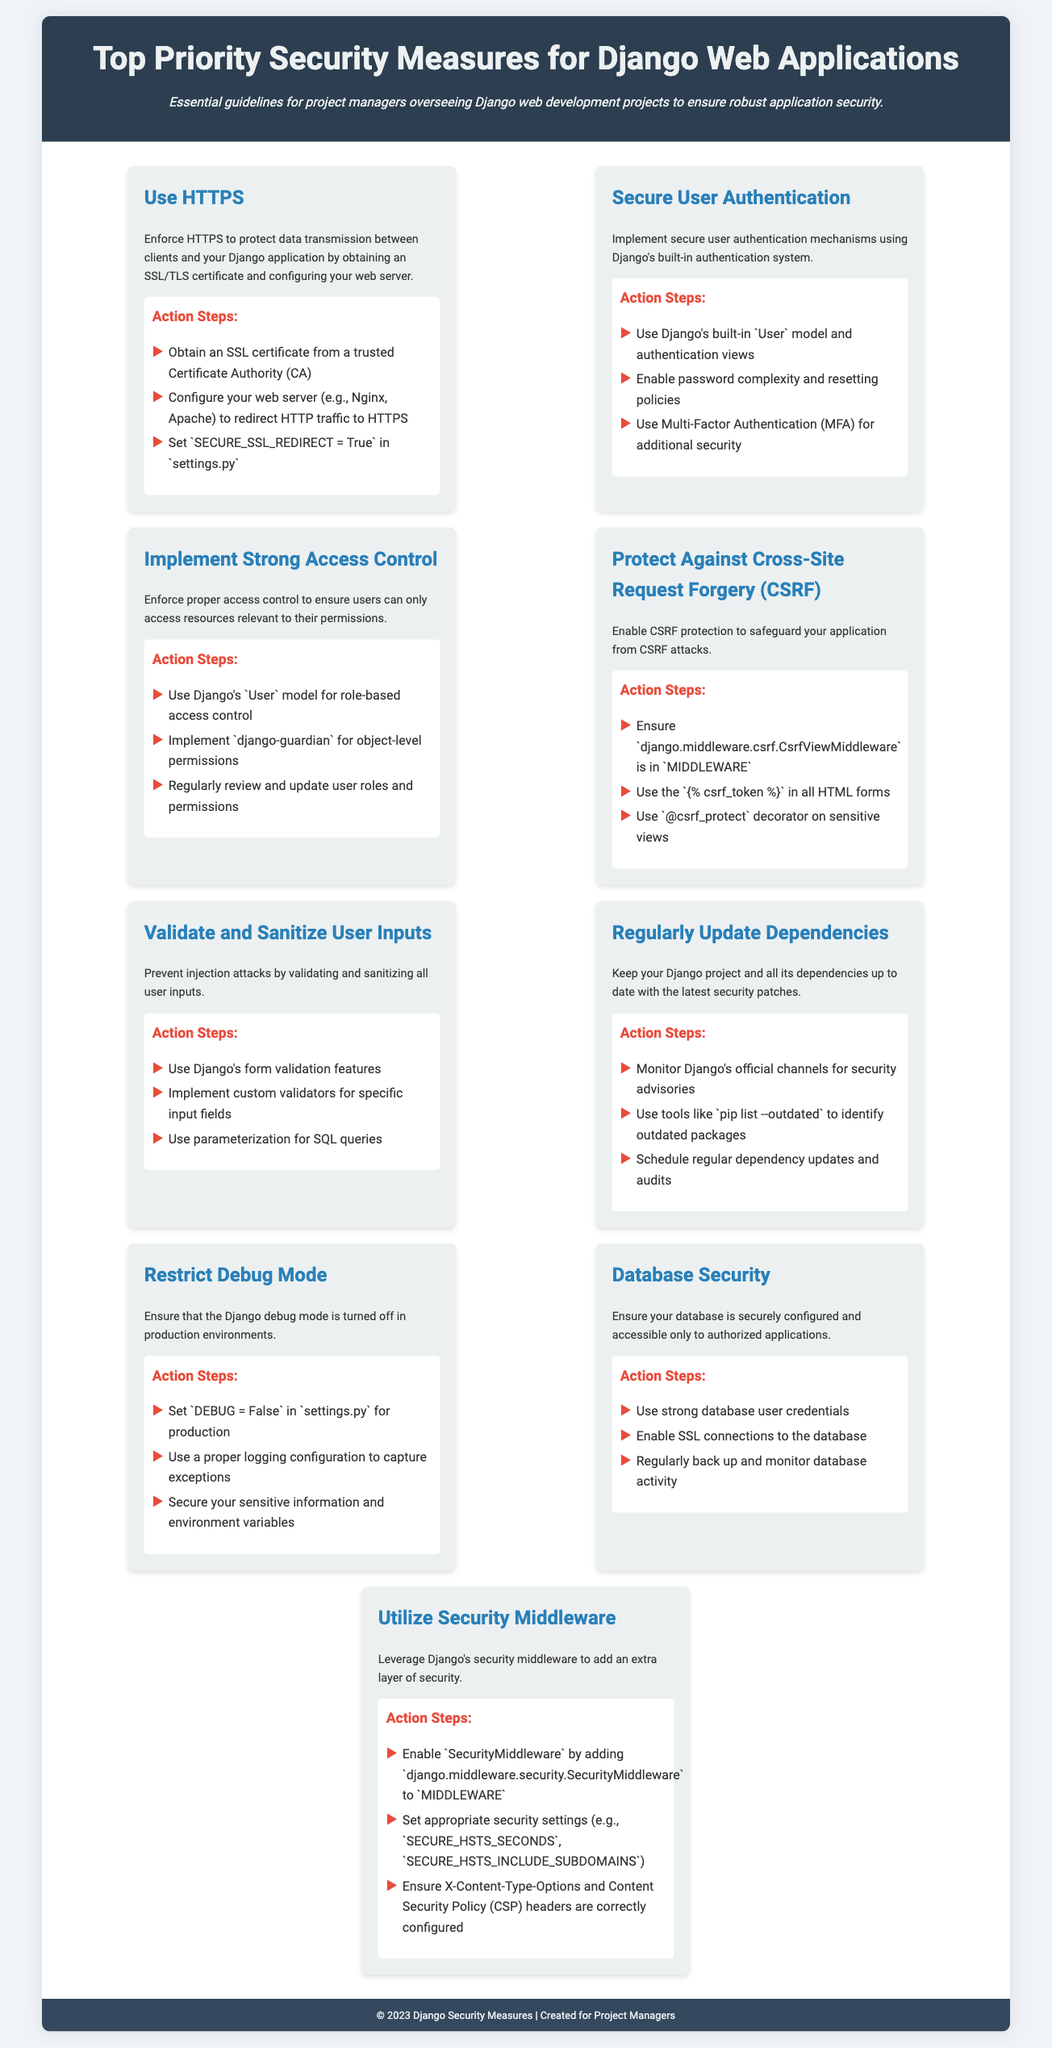What is the title of the document? The title is prominently displayed at the top of the document, summarizing its content.
Answer: Top Priority Security Measures for Django Web Applications How many security measures are listed in the document? The document provides a list of key points regarding security, which can be counted.
Answer: Nine What should be set to True to enforce HTTPS? This specific setting is mentioned in the HTTPS section as crucial for redirecting traffic.
Answer: SECURE_SSL_REDIRECT Which authentication method is recommended for additional security? The document mentions a specific method to enhance user authentication security.
Answer: Multi-Factor Authentication What is the main purpose of using Django's form validation features? The document elaborates on specific purposes of validation to strengthen security against threats.
Answer: Prevent injection attacks What file should the debug mode be set to False in? This specific configuration file is crucial for adjusting security settings in production.
Answer: settings.py Which middleware should be enabled for additional security? The document specifies a particular component for enhancing security measures.
Answer: SecurityMiddleware What actions should be taken to regularly maintain security? A specific step mentioned involves periodic monitoring for security advisories.
Answer: Schedule regular dependency updates and audits Which security measure involves using "django-guardian"? This measure is specifically mentioned in the context of managing user access and permissions.
Answer: Implement Strong Access Control 